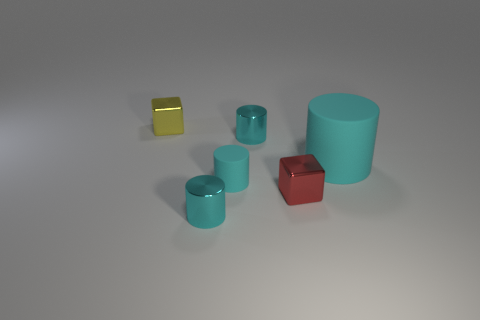How many cyan cylinders must be subtracted to get 2 cyan cylinders? 2 Add 3 green matte spheres. How many objects exist? 9 Subtract all red cylinders. Subtract all green balls. How many cylinders are left? 4 Subtract all cylinders. How many objects are left? 2 Subtract all small brown matte blocks. Subtract all tiny metallic cylinders. How many objects are left? 4 Add 2 large cylinders. How many large cylinders are left? 3 Add 6 cyan cylinders. How many cyan cylinders exist? 10 Subtract 0 green cylinders. How many objects are left? 6 